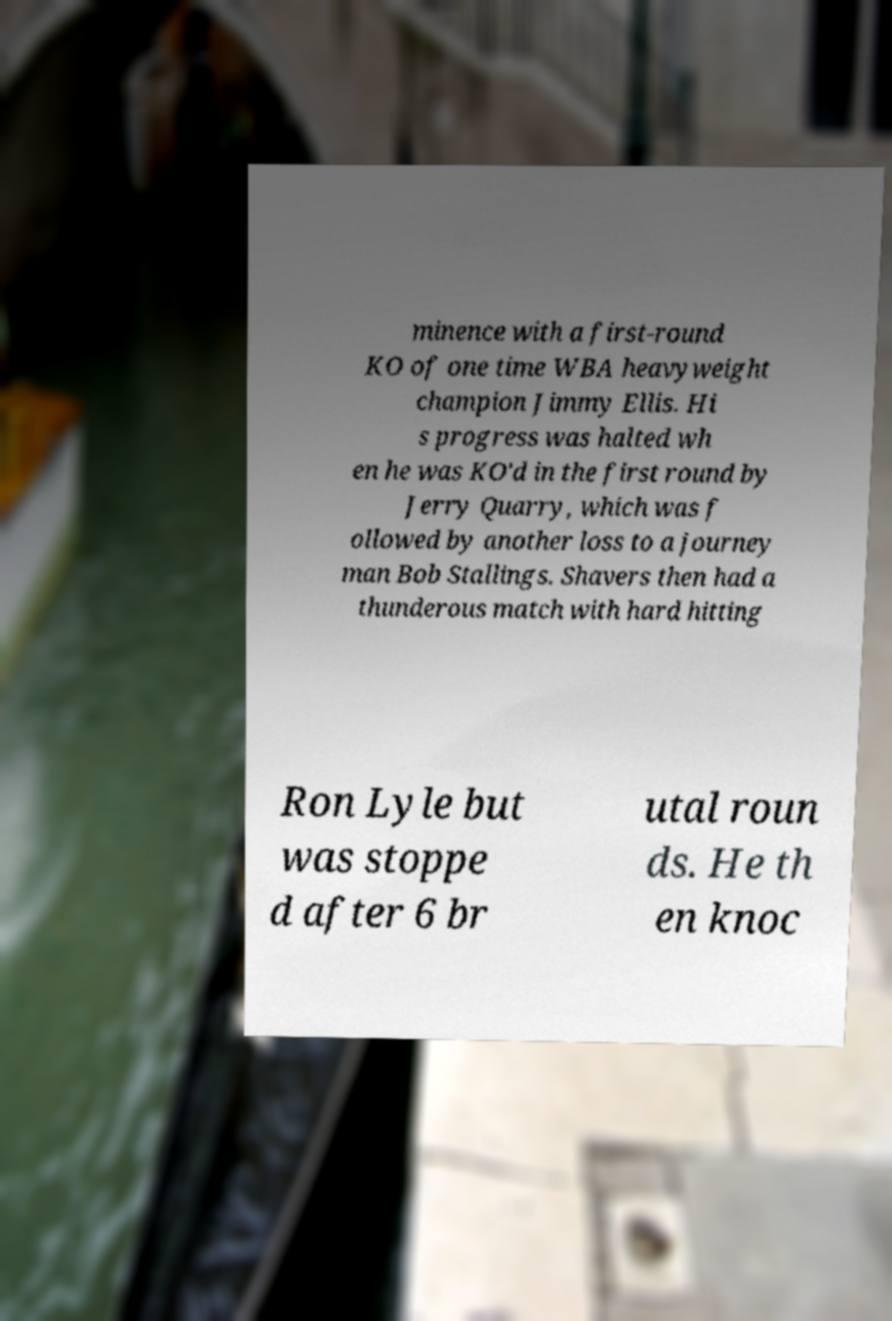Please identify and transcribe the text found in this image. minence with a first-round KO of one time WBA heavyweight champion Jimmy Ellis. Hi s progress was halted wh en he was KO'd in the first round by Jerry Quarry, which was f ollowed by another loss to a journey man Bob Stallings. Shavers then had a thunderous match with hard hitting Ron Lyle but was stoppe d after 6 br utal roun ds. He th en knoc 